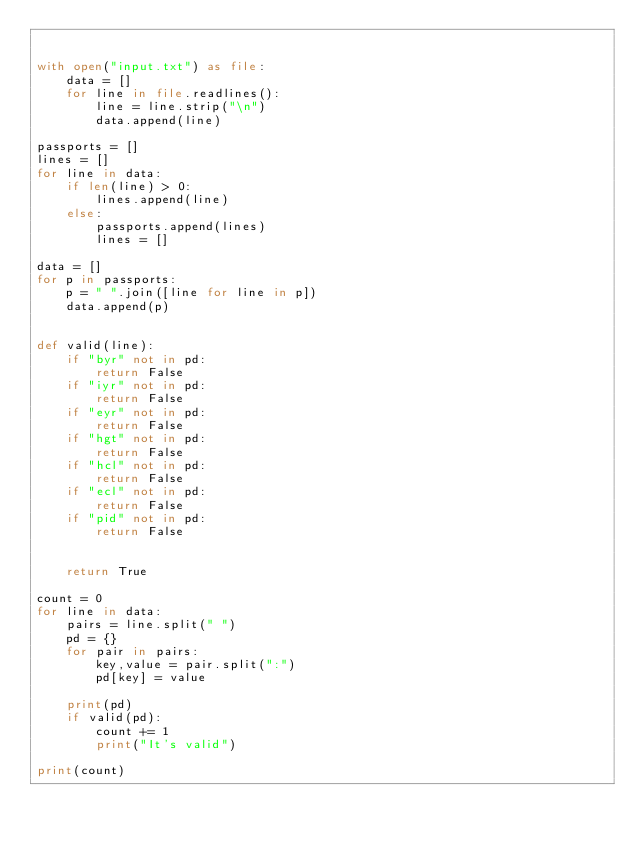<code> <loc_0><loc_0><loc_500><loc_500><_Python_>

with open("input.txt") as file:
    data = []
    for line in file.readlines():
        line = line.strip("\n")
        data.append(line)

passports = []
lines = []
for line in data:
    if len(line) > 0:
        lines.append(line)
    else:
        passports.append(lines)
        lines = []

data = []
for p in passports:
    p = " ".join([line for line in p])
    data.append(p)


def valid(line):
    if "byr" not in pd:
        return False
    if "iyr" not in pd:
        return False
    if "eyr" not in pd:
        return False
    if "hgt" not in pd:
        return False
    if "hcl" not in pd:
        return False
    if "ecl" not in pd:
        return False
    if "pid" not in pd:
        return False
    

    return True

count = 0
for line in data:
    pairs = line.split(" ")
    pd = {}
    for pair in pairs:
        key,value = pair.split(":")
        pd[key] = value

    print(pd)
    if valid(pd):
        count += 1
        print("It's valid")

print(count)
    </code> 